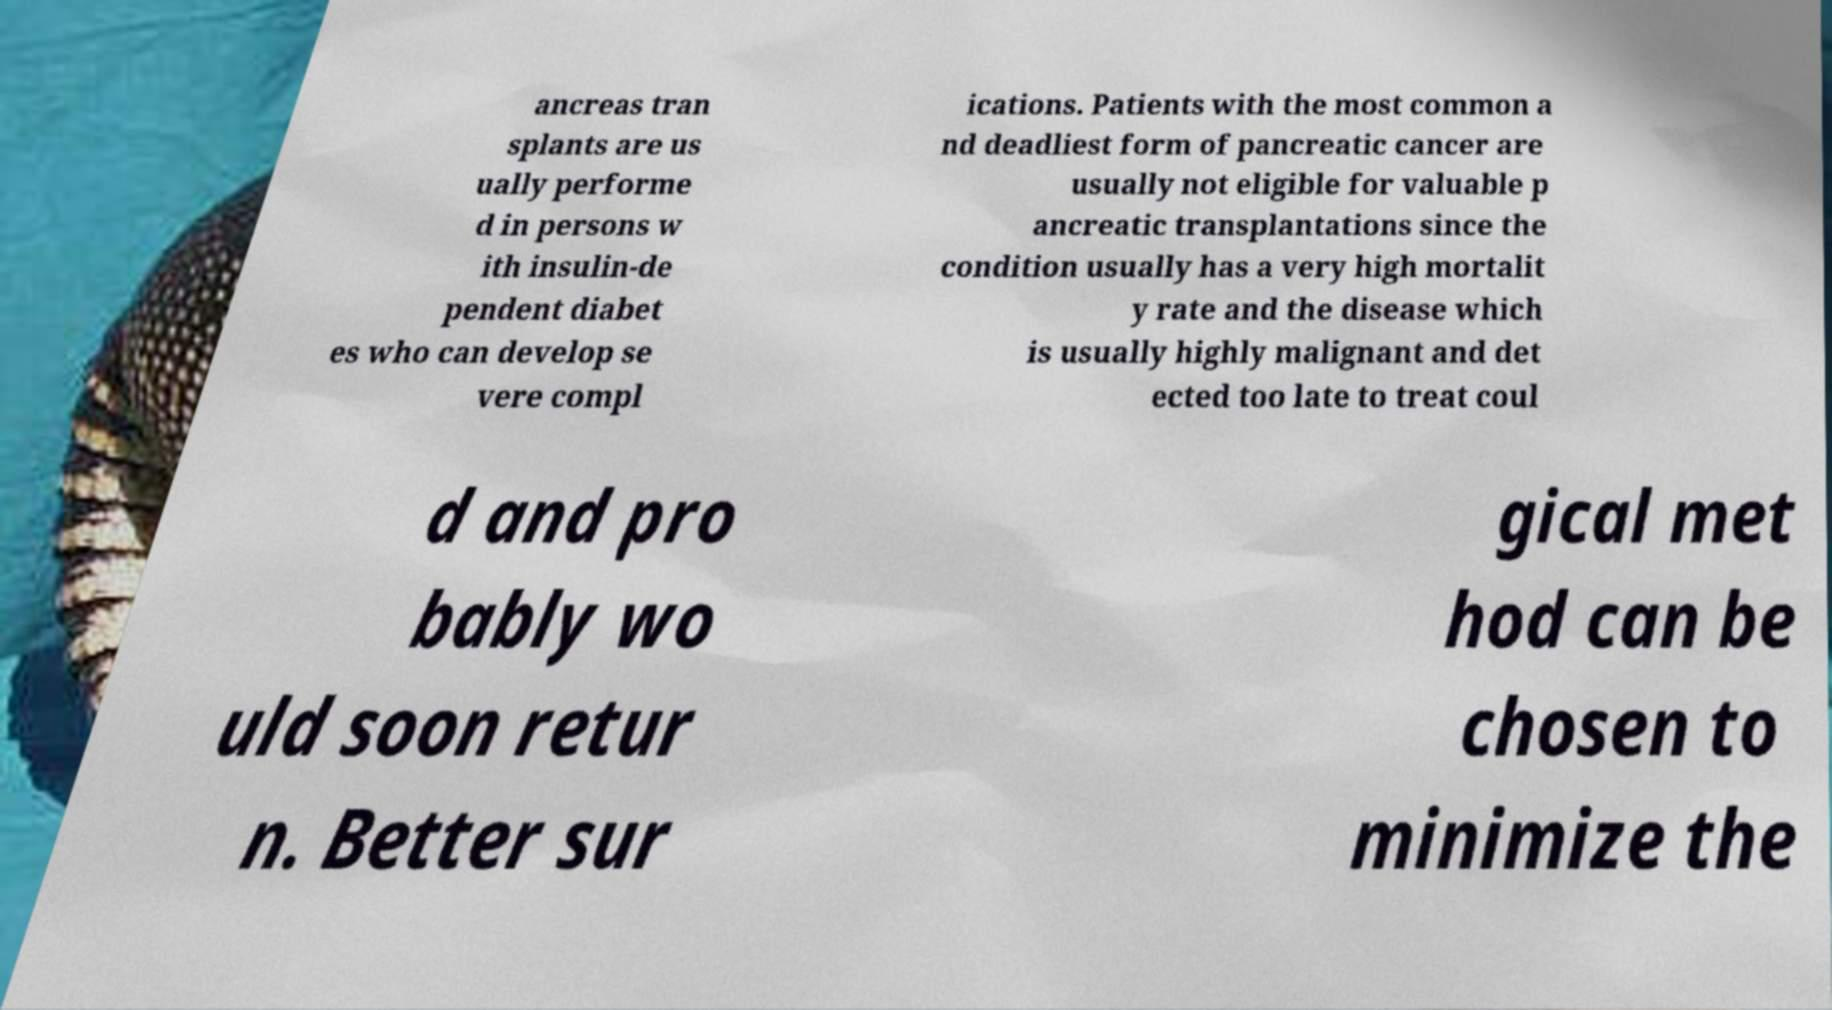What messages or text are displayed in this image? I need them in a readable, typed format. ancreas tran splants are us ually performe d in persons w ith insulin-de pendent diabet es who can develop se vere compl ications. Patients with the most common a nd deadliest form of pancreatic cancer are usually not eligible for valuable p ancreatic transplantations since the condition usually has a very high mortalit y rate and the disease which is usually highly malignant and det ected too late to treat coul d and pro bably wo uld soon retur n. Better sur gical met hod can be chosen to minimize the 